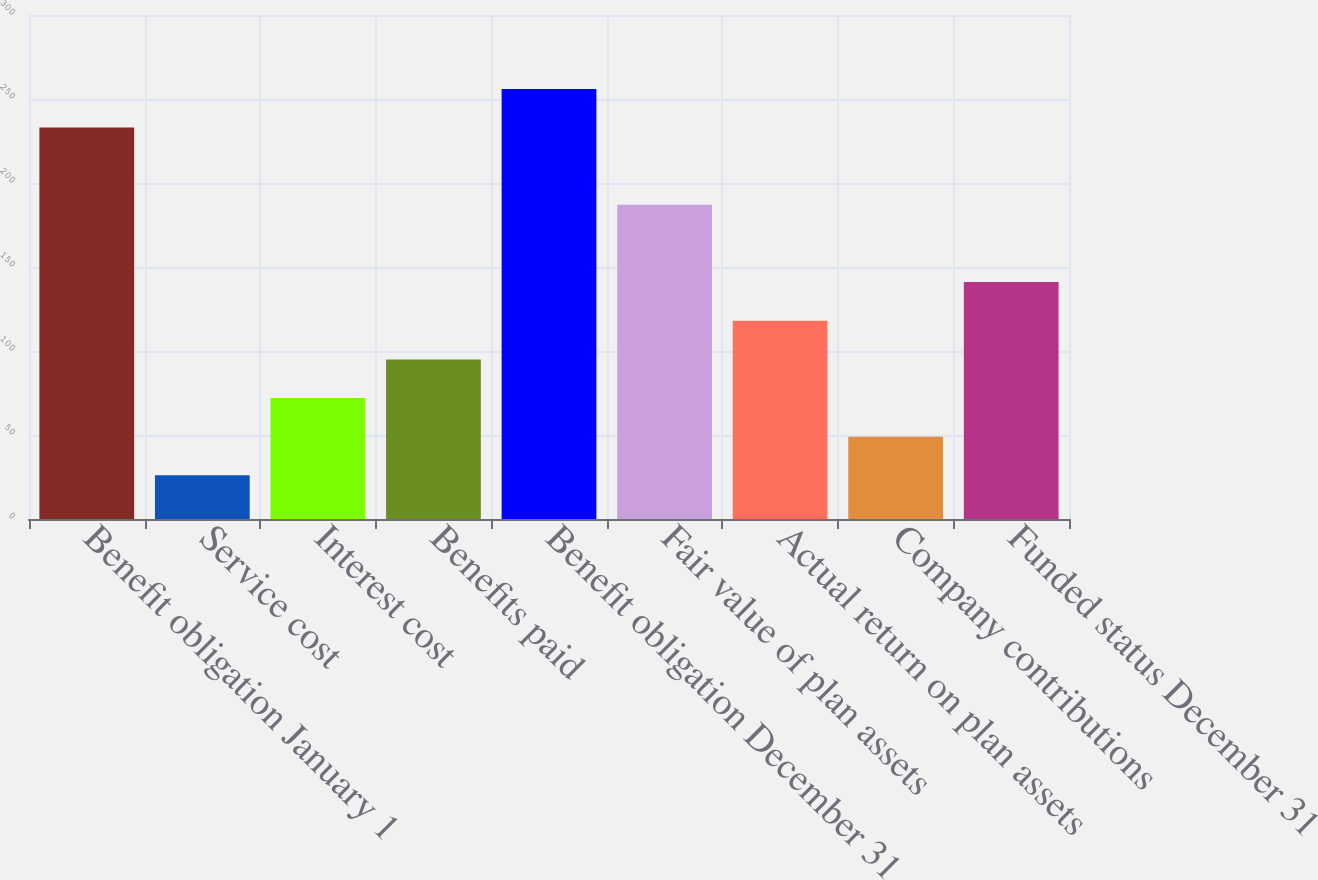<chart> <loc_0><loc_0><loc_500><loc_500><bar_chart><fcel>Benefit obligation January 1<fcel>Service cost<fcel>Interest cost<fcel>Benefits paid<fcel>Benefit obligation December 31<fcel>Fair value of plan assets<fcel>Actual return on plan assets<fcel>Company contributions<fcel>Funded status December 31<nl><fcel>233<fcel>26<fcel>72<fcel>95<fcel>256<fcel>187<fcel>118<fcel>49<fcel>141<nl></chart> 